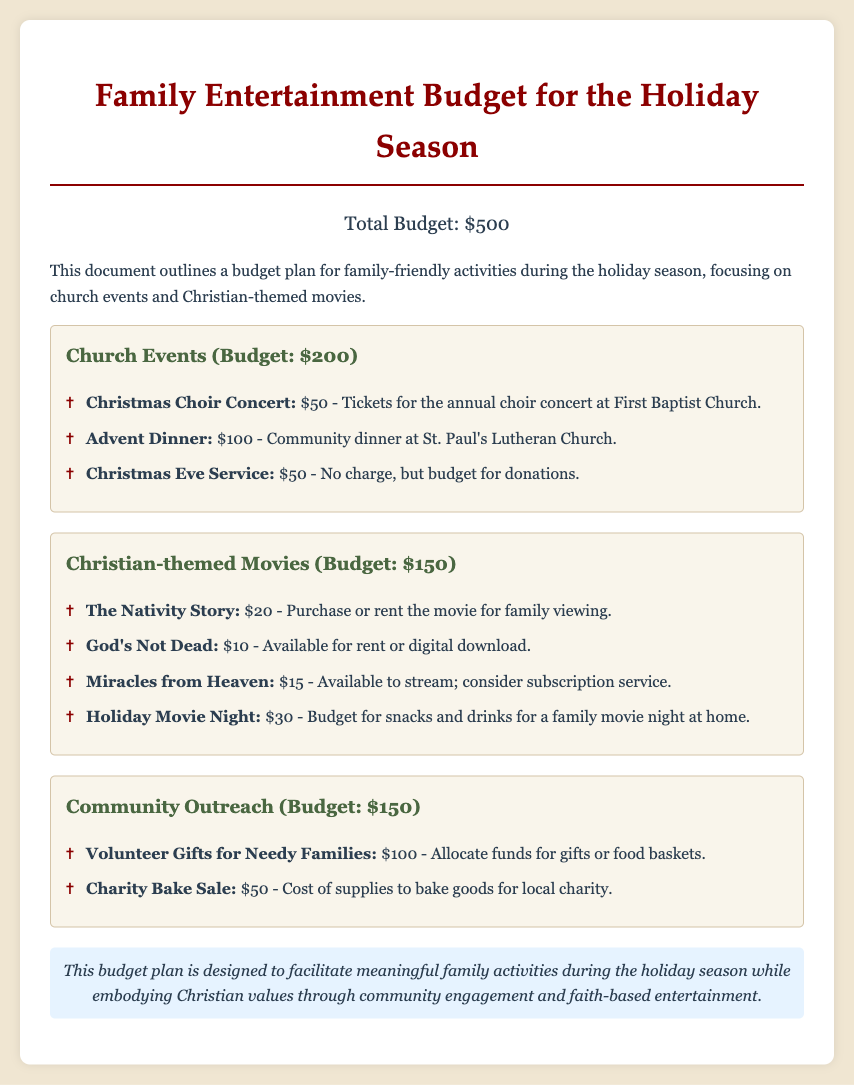What is the total budget? The total budget is presented at the beginning of the document as the amount allocated for family entertainment.
Answer: $500 How much is allocated for church events? The funding for church-related activities is outlined in a specific section of the document.
Answer: $200 What is the cost of the Christmas Choir Concert? The cost for attending the Christmas Choir Concert is individually listed as part of the church events budget.
Answer: $50 What movie is budgeted for $10? The document includes a list of movies and their respective costs, including this specific price point.
Answer: God's Not Dead How much is budgeted for snacks and drinks for movie night? There is a separate item allocated for refreshments in a family movie night, indicating the focus on home entertainment.
Answer: $30 How much is allocated for volunteer gifts for needy families? The budget for outreach efforts highlights the community support initiative with a specific dollar amount.
Answer: $100 What is the primary focus of this budget plan? The document outlines the main goal of the financial allocation based on its themes and activities.
Answer: Family-friendly activities How many church events are listed in the document? The document lists a distinct number of church-related activities under the corresponding budget category.
Answer: 3 What movie is mentioned for family viewing? The section that addresses movie entertainment includes options suitable for family viewing during the holiday.
Answer: The Nativity Story 